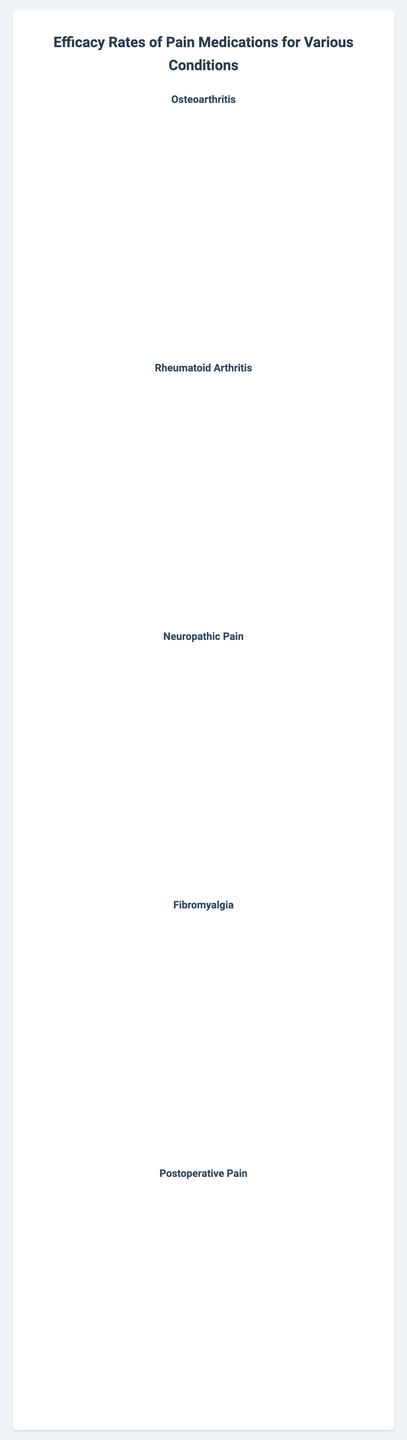What is the efficacy rate of Ibuprofen for Osteoarthritis? Locate the bar corresponding to Ibuprofen under the Osteoarthritis section of the chart to see that it reaches the 70% mark
Answer: 70% Which medication has the highest efficacy rate for Rheumatoid Arthritis? Look at the bar heights in the Rheumatoid Arthritis section and identify the tallest one, which corresponds to Methotrexate at 75%
Answer: Methotrexate Compare the efficacy rates of Gabapentin and Pregabalin for Neuropathic Pain. Which one is higher and by how much? Check the Neuropathic Pain section and note the bar heights: Gabapentin at 65% and Pregabalin at 70%. The difference is 70% - 65% = 5%
Answer: Pregabalin by 5% What is the average efficacy rate of medications for Postoperative Pain? Sum the efficacy rates of Morphine (85%), Oxycodone (80%), Ibuprofen (50%), and Acetaminophen (45%), then divide by the number of medications: (85 + 80 + 50 + 45) / 4 = 65%
Answer: 65% Which condition has the highest average efficacy rate for its medications, and what is the value? Compare average efficacy rates across conditions. Calculate: Osteoarthritis ((70+55+60+65)/4=62.5), Rheumatoid Arthritis ((75+68+60+55)/4=64.5), Neuropathic Pain ((65+70+55+60)/4=62.5), Fibromyalgia ((60+65+58+62)/4=61.25), Postoperative Pain ((85+80+50+45)/4=65). Postoperative Pain has the highest at 65%
Answer: Postoperative Pain, 65% Identify the medication with the lowest efficacy rate for Fibromyalgia and specify the rate. Locate the shortest bar in the Fibromyalgia section, which corresponds to Duloxetine at 58%
Answer: Duloxetine, 58% Is there any medication with an efficacy rate equal to 60% for any condition? If so, name it/them and the condition(s). Identify bars reaching the 60% mark. For Osteoarthritis, Naproxen (60%), Rheumatoid Arthritis, Sulfasalazine (60%), Neuropathic Pain, Amitriptyline (60%), Fibromyalgia, Milnacipran (60%)
Answer: Naproxen (Osteoarthritis), Sulfasalazine (Rheumatoid Arthritis), Amitriptyline (Neuropathic Pain), Milnacipran (Fibromyalgia) What is the total difference in efficacy rates between Morphine and Acetaminophen for Postoperative Pain? Calculate the absolute difference: Morphine (85%) - Acetaminophen (45%) = 40%
Answer: 40% For Neuropathic Pain, which medication has a darker color shade and what is its efficacy rate? Identify medications with darker blue color, in this case, Pregabalin and Amitriptyline. Check their effectiveness: Pregabalin (70%) is higher than Amitriptyline (60%).
Answer: Pregabalin, 70% What is the sum of efficacy rates of Celecoxib for Osteoarthritis and Amitriptyline for Fibromyalgia? Add their efficacy rates: Celecoxib (65%) and Amitriptyline (62%). 65% + 62% = 127%
Answer: 127% 